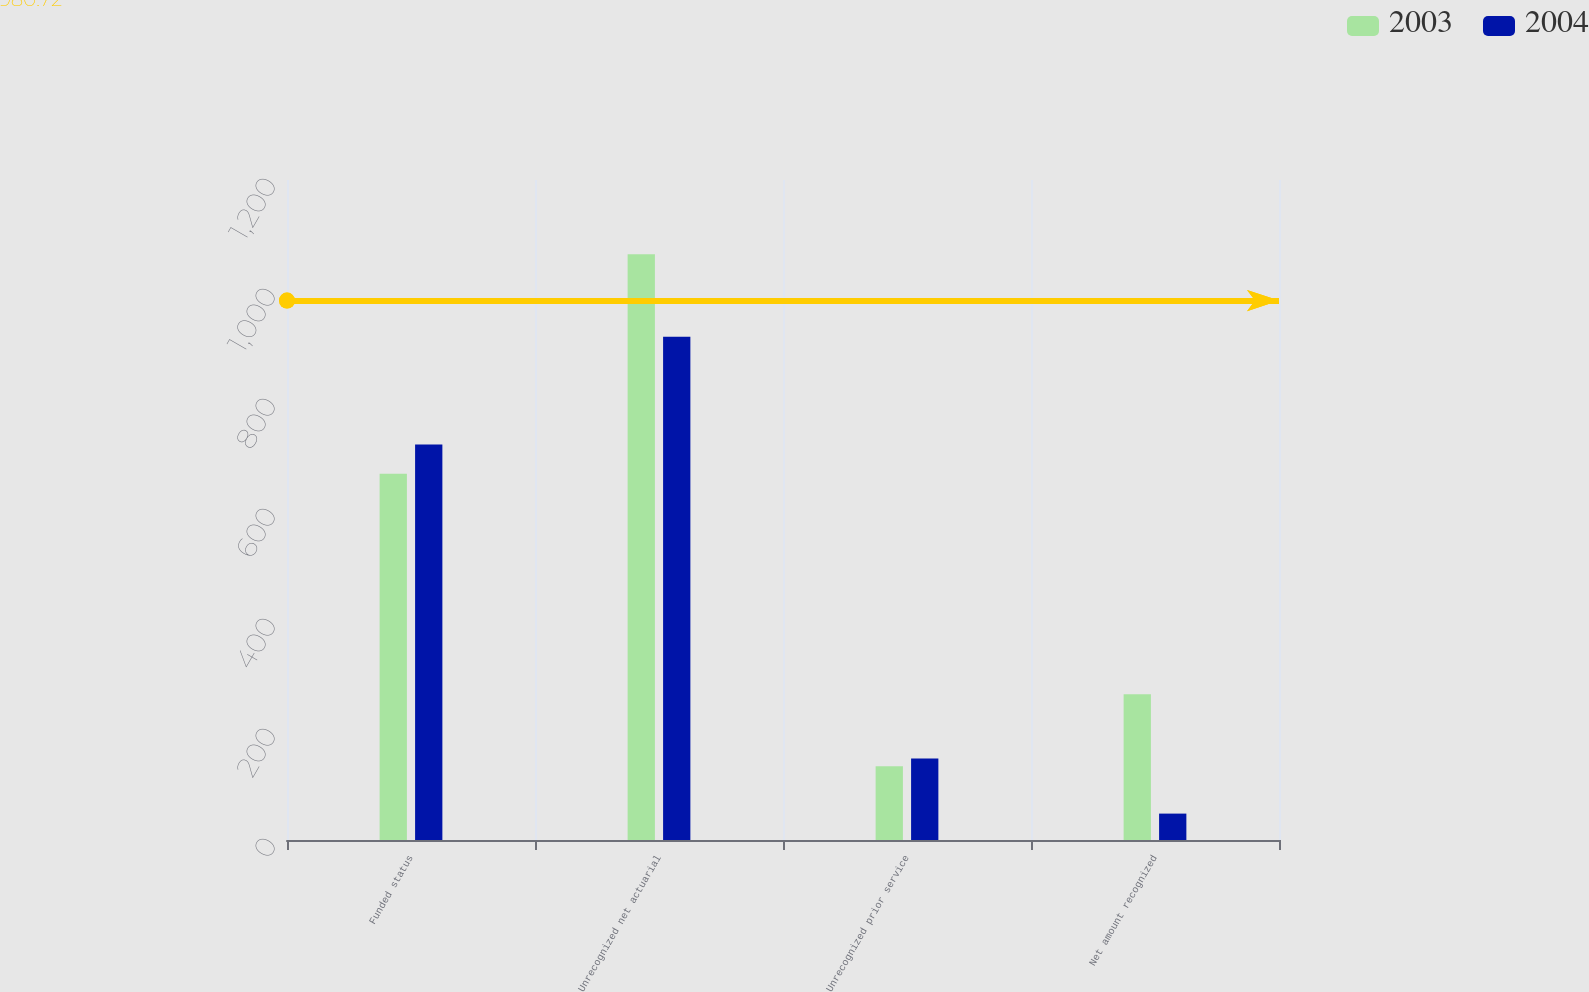Convert chart to OTSL. <chart><loc_0><loc_0><loc_500><loc_500><stacked_bar_chart><ecel><fcel>Funded status<fcel>Unrecognized net actuarial<fcel>Unrecognized prior service<fcel>Net amount recognized<nl><fcel>2003<fcel>666<fcel>1065<fcel>134<fcel>265<nl><fcel>2004<fcel>719<fcel>915<fcel>148<fcel>48<nl></chart> 